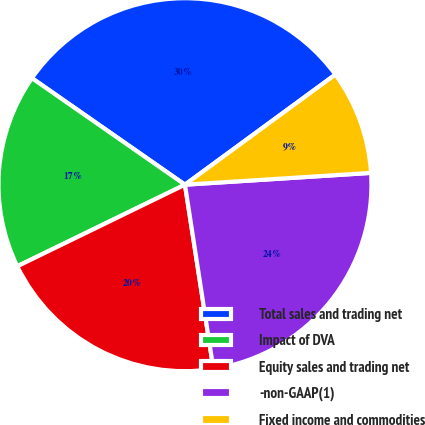<chart> <loc_0><loc_0><loc_500><loc_500><pie_chart><fcel>Total sales and trading net<fcel>Impact of DVA<fcel>Equity sales and trading net<fcel>-non-GAAP(1)<fcel>Fixed income and commodities<nl><fcel>30.26%<fcel>16.89%<fcel>20.23%<fcel>23.57%<fcel>9.05%<nl></chart> 